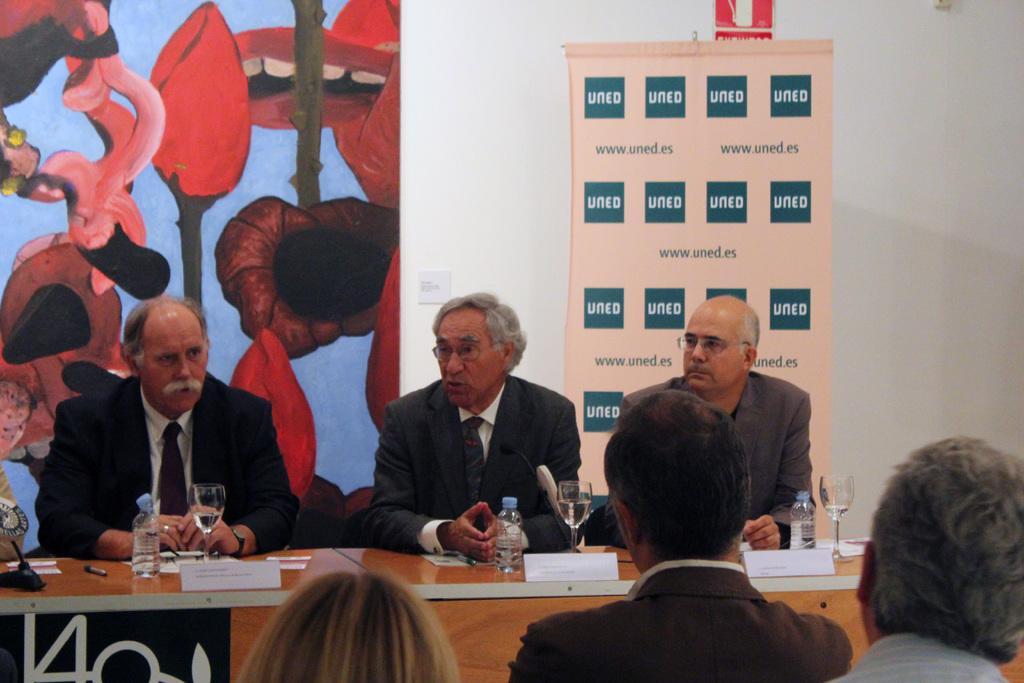In one or two sentences, can you explain what this image depicts? In this picture, There is a table which is in yellow color on that table there are some glasses and there are some bottles and there are some people sitting on the chairs around the table, In the background there is a red color poster and there is a white color wall. 